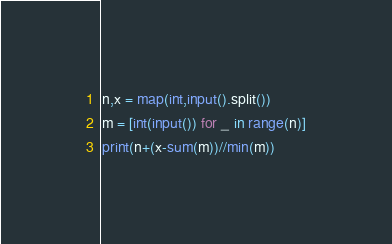<code> <loc_0><loc_0><loc_500><loc_500><_Python_>n,x = map(int,input().split())
m = [int(input()) for _ in range(n)]
print(n+(x-sum(m))//min(m))</code> 